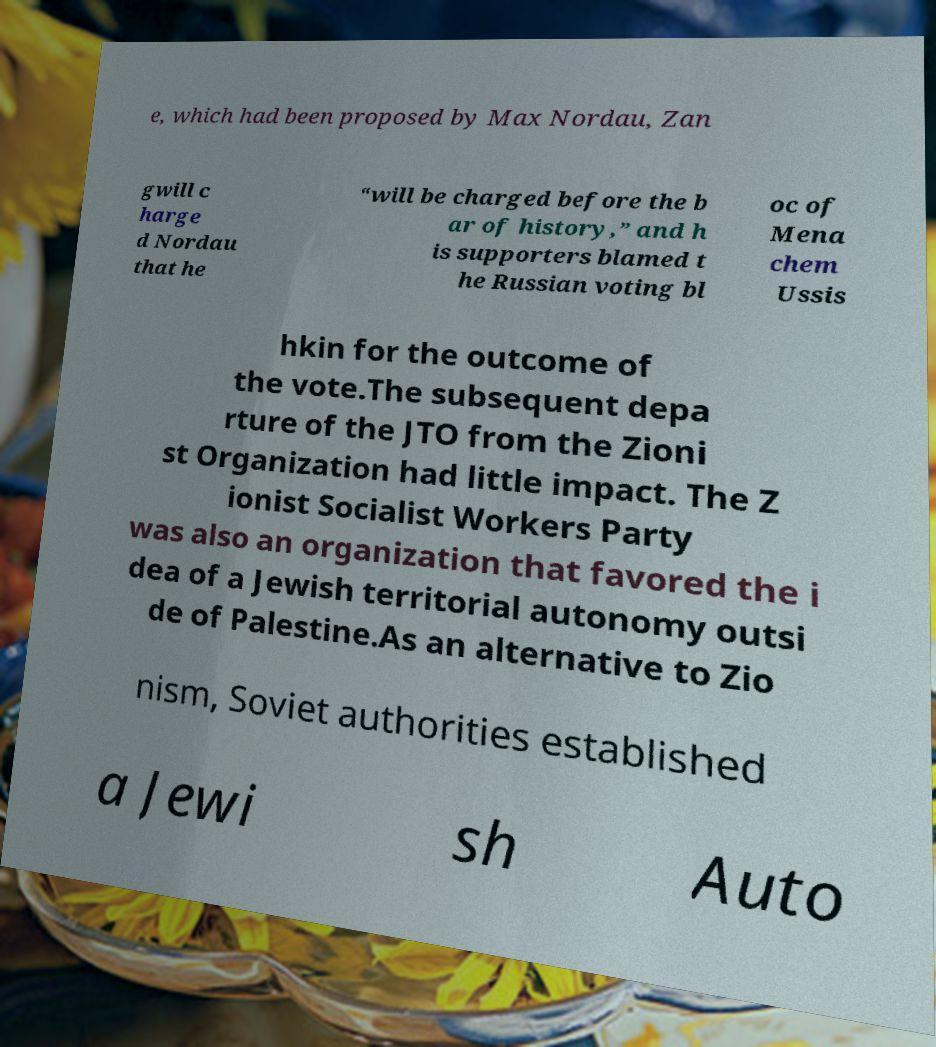For documentation purposes, I need the text within this image transcribed. Could you provide that? e, which had been proposed by Max Nordau, Zan gwill c harge d Nordau that he “will be charged before the b ar of history,” and h is supporters blamed t he Russian voting bl oc of Mena chem Ussis hkin for the outcome of the vote.The subsequent depa rture of the JTO from the Zioni st Organization had little impact. The Z ionist Socialist Workers Party was also an organization that favored the i dea of a Jewish territorial autonomy outsi de of Palestine.As an alternative to Zio nism, Soviet authorities established a Jewi sh Auto 